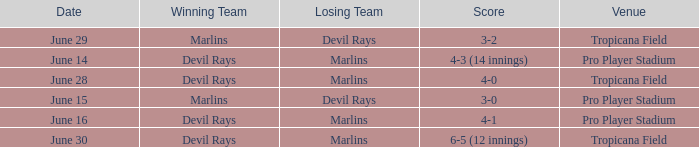What was the score on june 16? 4-1. 